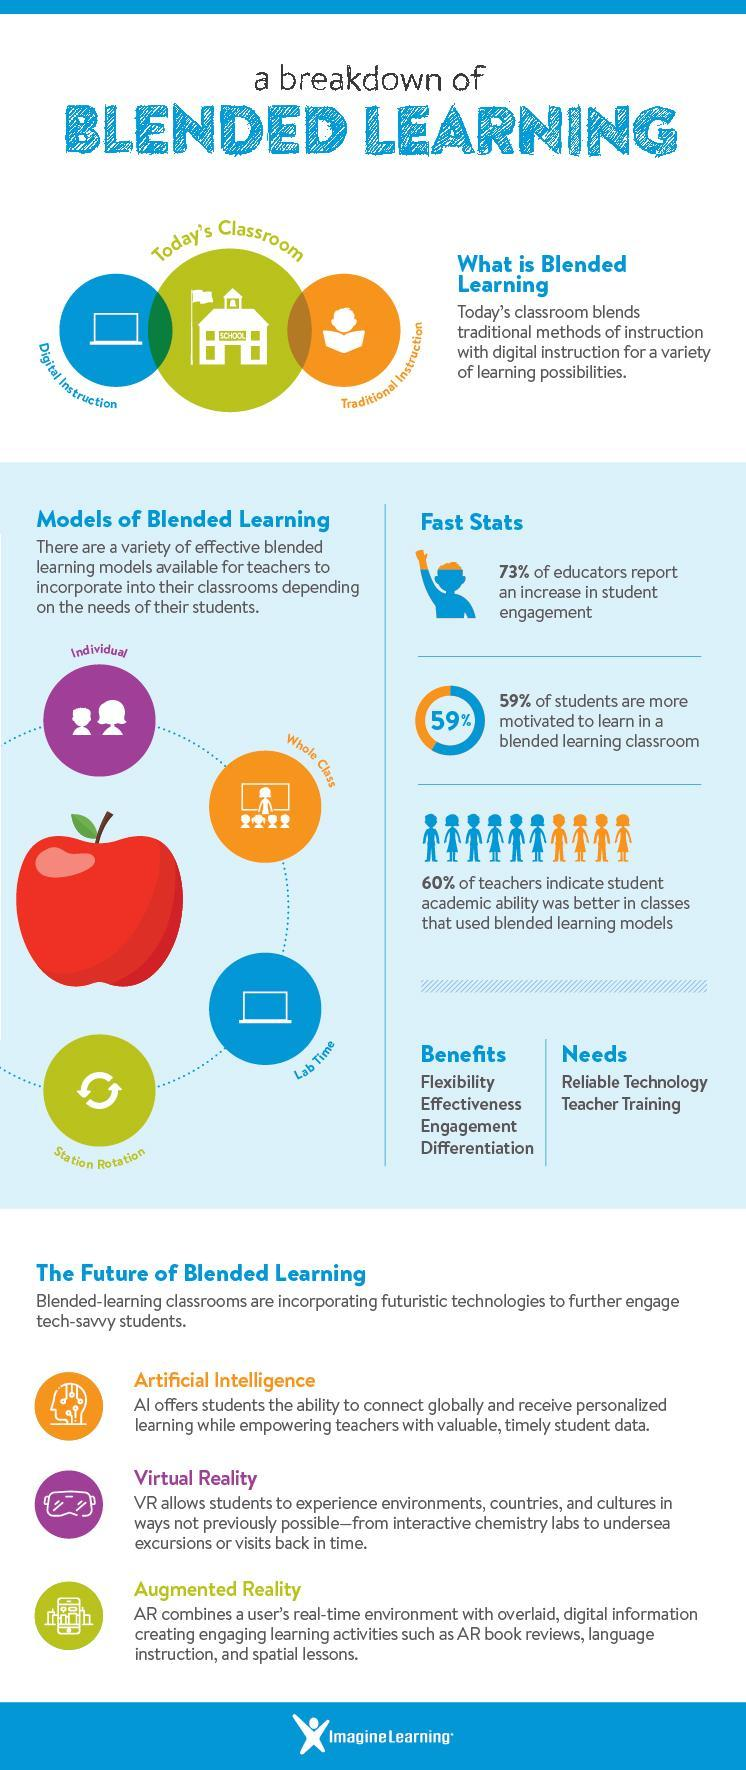What percentage of students are more motivated to learn in a blended learning classroom?
Answer the question with a short phrase. 59% What percentage of educators do not report an increase in the student engagement in blended learning? 27% 